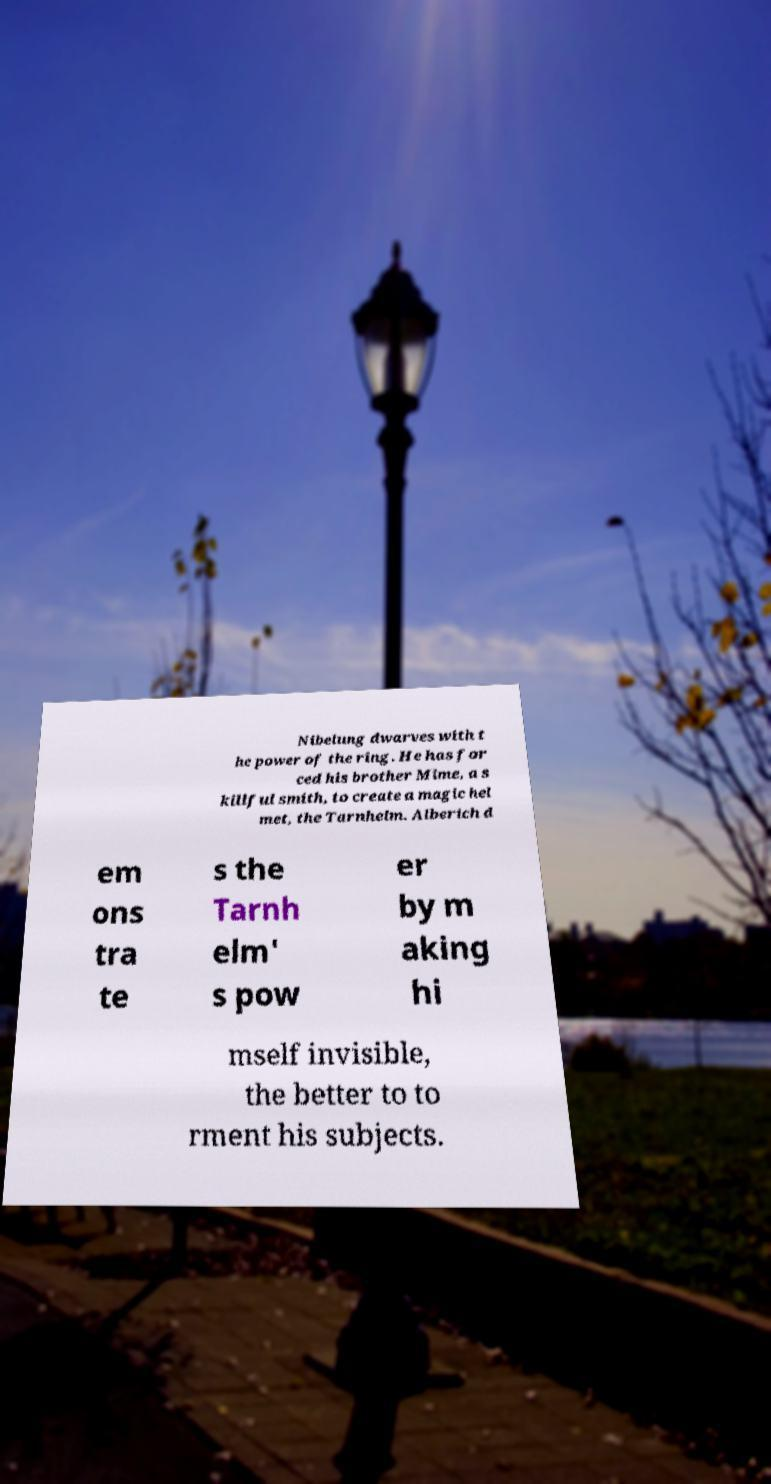Can you accurately transcribe the text from the provided image for me? Nibelung dwarves with t he power of the ring. He has for ced his brother Mime, a s killful smith, to create a magic hel met, the Tarnhelm. Alberich d em ons tra te s the Tarnh elm' s pow er by m aking hi mself invisible, the better to to rment his subjects. 